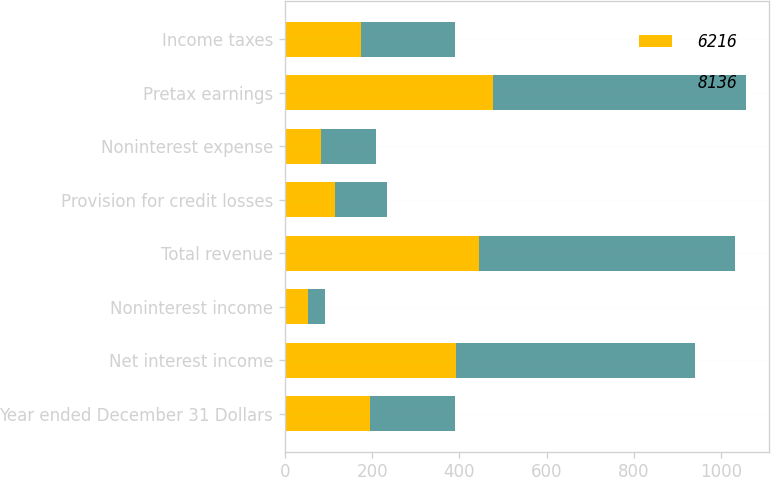Convert chart. <chart><loc_0><loc_0><loc_500><loc_500><stacked_bar_chart><ecel><fcel>Year ended December 31 Dollars<fcel>Net interest income<fcel>Noninterest income<fcel>Total revenue<fcel>Provision for credit losses<fcel>Noninterest expense<fcel>Pretax earnings<fcel>Income taxes<nl><fcel>6216<fcel>194.5<fcel>392<fcel>53<fcel>445<fcel>114<fcel>83<fcel>476<fcel>175<nl><fcel>8136<fcel>194.5<fcel>547<fcel>40<fcel>587<fcel>119<fcel>125<fcel>581<fcel>214<nl></chart> 